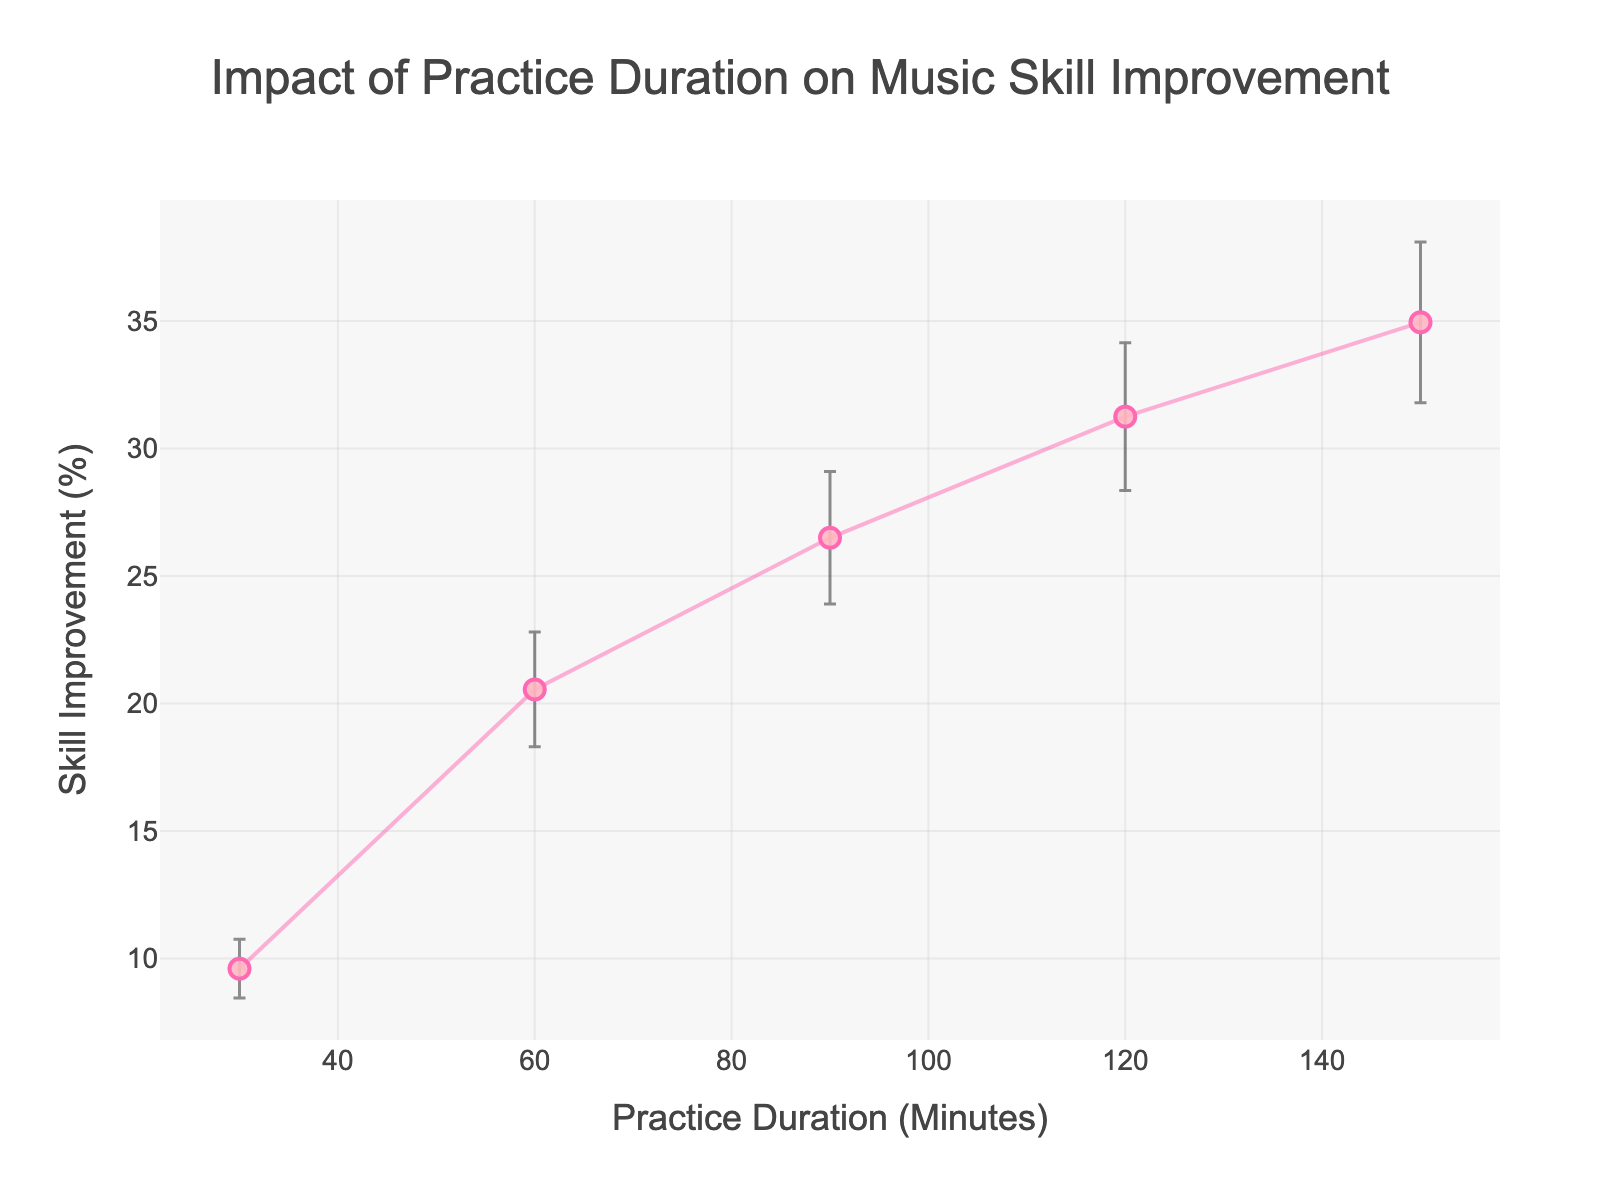What's the title of this figure? The title of the figure is displayed at the top of the plot. It reads, "Impact of Practice Duration on Music Skill Improvement."
Answer: Impact of Practice Duration on Music Skill Improvement What is the practice duration that shows the highest average skill improvement? By looking at the x-axis and corresponding points on the y-axis, the practice duration of 150 minutes shows the highest average skill improvement at around 35%.
Answer: 150 minutes What's the color and size of the markers in the plot? The markers are pink and they are a medium size with the detailed information describing them having a size of 10.
Answer: Pink and medium How does the skill improvement change as practice duration increases from 30 to 150 minutes? As we observe the trend from left to right along the x-axis, the skill improvement percentages increase from around 10% at 30 minutes to about 35% at 150 minutes, indicating a positive relationship between practice duration and skill improvement.
Answer: It increases Which practice duration shows skill improvement with the thinnest error margin? Comparing the lengths of the error bars, the practice duration of 30 minutes exhibits the thinnest margin of error.
Answer: 30 minutes How does the margin of error change as practice duration increases? By analyzing the error bars, we see that the margin of error generally increases as the practice duration increases, which means there is more variability in the skill improvement percentages for longer practice durations.
Answer: It increases What is the average skill improvement for 90 minutes of practice? The y-axis shows that for a practice duration of 90 minutes, the average skill improvement is around 26.5%.
Answer: 26.5% Compare the skill improvement gains between 60 and 120 minutes of practice. At 60 minutes, the skill improvement is around 20.5%, while at 120 minutes, it rises to around 31.25%, showing a considerable increase as practice time doubles.
Answer: The gain is about 10.75% If you were to compare the variability in skill improvement for 30 and 150 minutes of practice, which one has more variability? The length of the error bars indicates the variability. The error bar for 150 minutes is longer than for 30 minutes, suggesting greater variability for 150 minutes of practice.
Answer: 150 minutes Is the relationship between practice duration and skill improvement linear, based on the plot? The plot shows a generally upward trend but the increase rate appears to slow down over time, which suggests the relationship is not perfectly linear but more of a diminishing returns effect.
Answer: No 